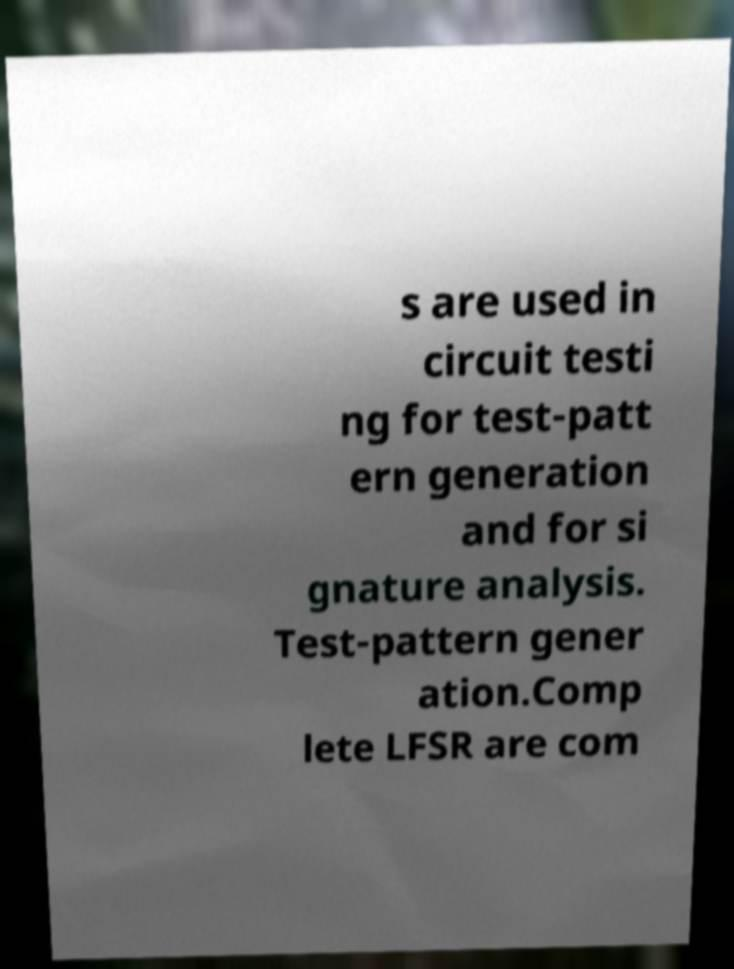Can you accurately transcribe the text from the provided image for me? s are used in circuit testi ng for test-patt ern generation and for si gnature analysis. Test-pattern gener ation.Comp lete LFSR are com 